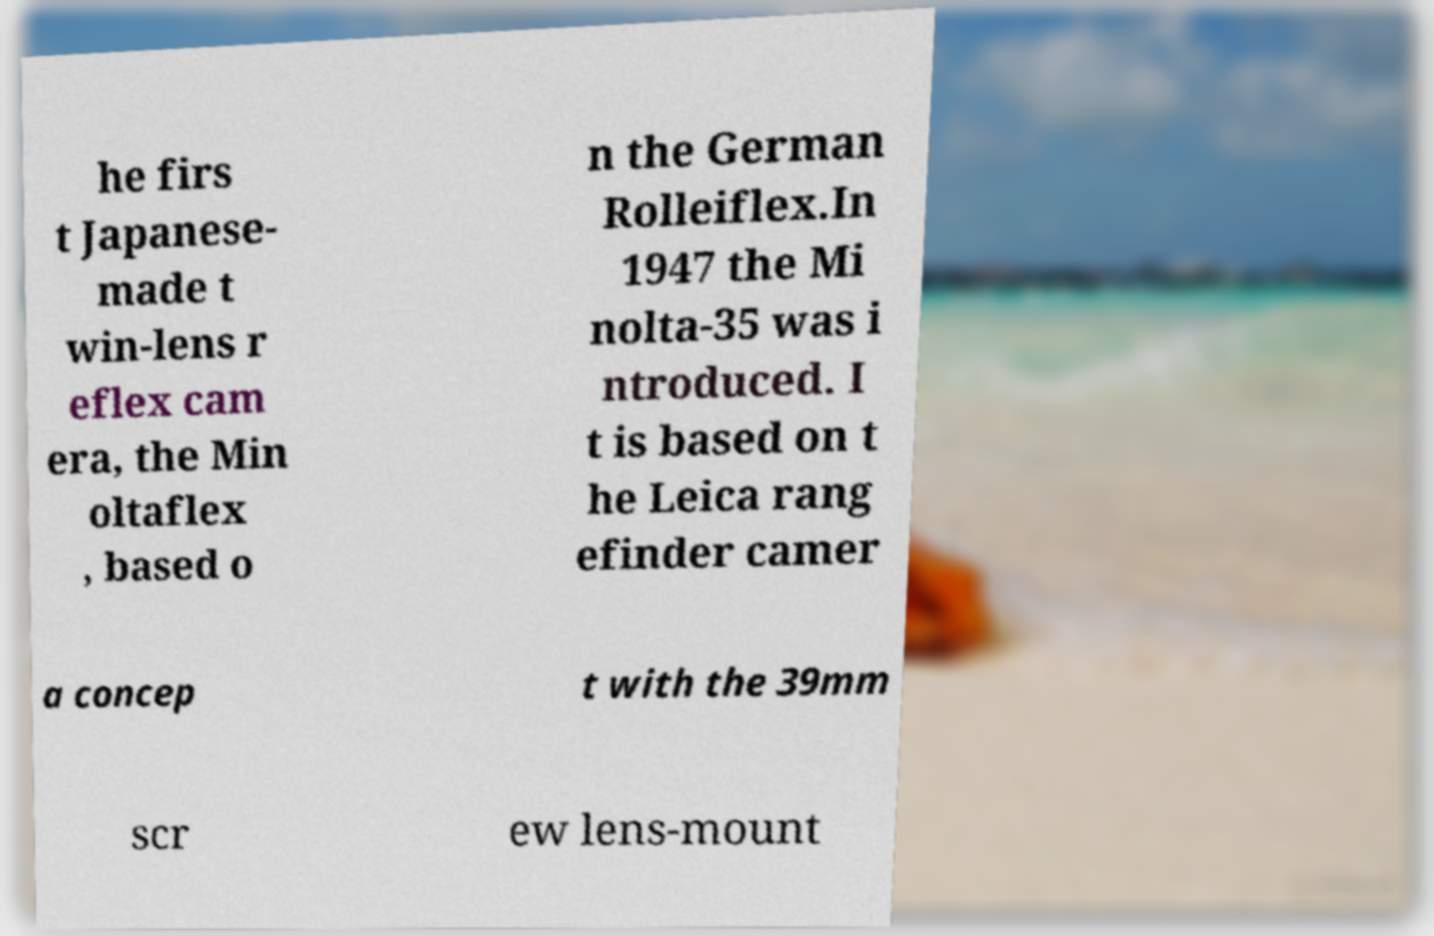Can you read and provide the text displayed in the image?This photo seems to have some interesting text. Can you extract and type it out for me? he firs t Japanese- made t win-lens r eflex cam era, the Min oltaflex , based o n the German Rolleiflex.In 1947 the Mi nolta-35 was i ntroduced. I t is based on t he Leica rang efinder camer a concep t with the 39mm scr ew lens-mount 